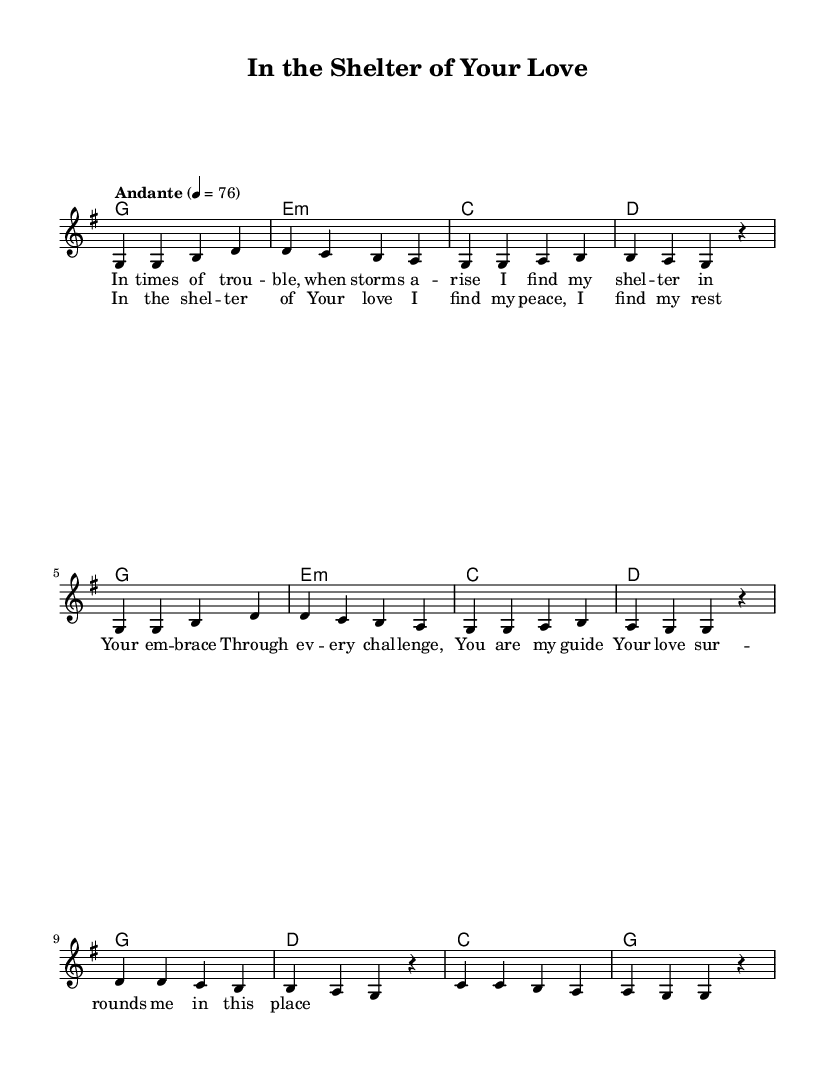What is the key signature of this music? The key signature is determined by looking at the beginning of the score, where it indicates which notes are sharp or flat. In this case, the key signature is G major, which has one sharp (F#).
Answer: G major What is the time signature of this music? The time signature appears at the beginning of the score and tells us how many beats are in each measure. Here, it is indicated as 4/4, meaning there are four beats per measure.
Answer: 4/4 What is the tempo marking of this music? The tempo marking is found above the staff and provides the speed of the piece, indicated as "Andante" with a metronome marking of 76 beats per minute.
Answer: Andante 76 What is the first lyric line of the verse? To find the first lyric line, look at the lyrics section that corresponds to the music notes in the verse. The first line reads, "In times of trouble, when storms arise."
Answer: In times of trouble, when storms arise How many measures are in the chorus? Counting the measures in the chorus section, there are a total of four measures indicated by the music notation.
Answer: 4 In which section do the lyrics mention finding peace? The lyrics referring to finding peace occur in the chorus section of the song, which emphasizes the theme of comfort within God's love.
Answer: chorus What type of chord is used in the second measure of the verse? The second measure of the verse is indicated as an E minor chord (e:m), which can be identified by looking at the chord symbols above the music staff.
Answer: E minor 